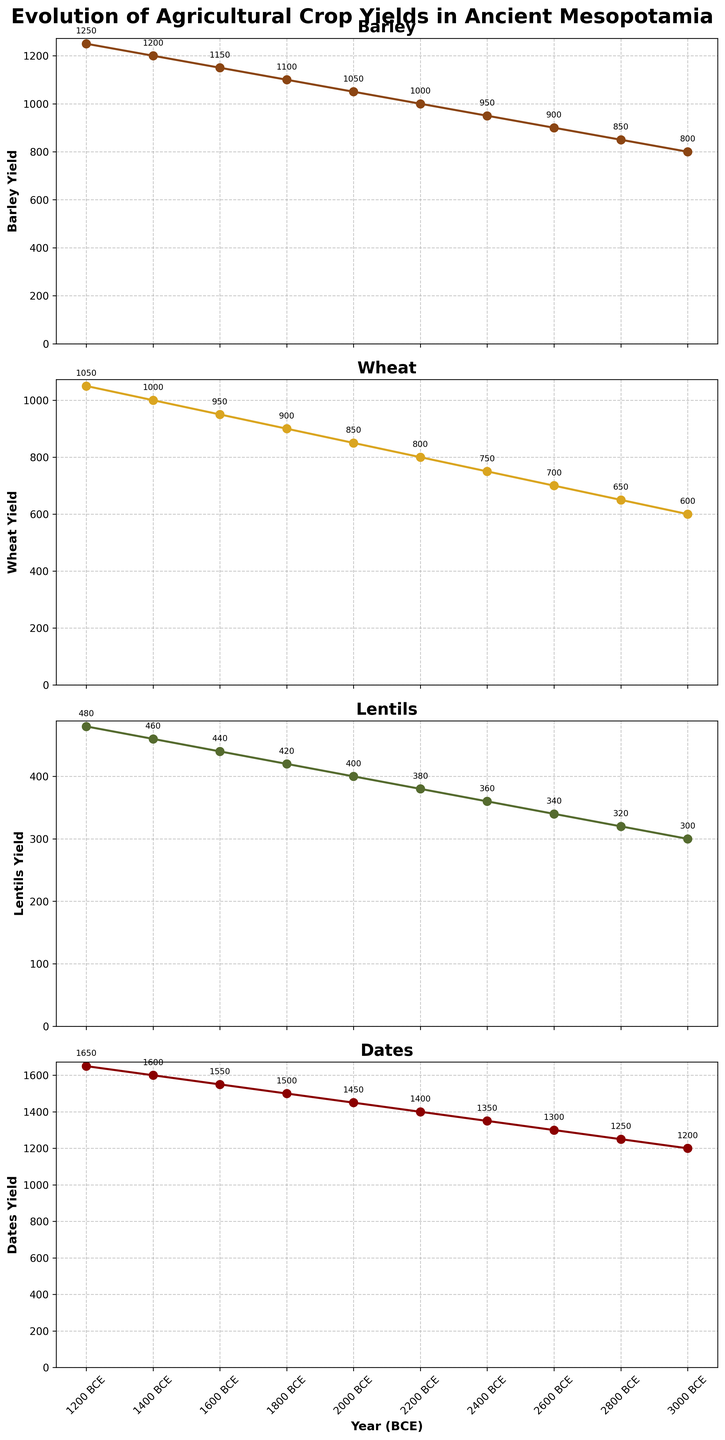What is the title of each subplot? Each subplot is titled with the name of the specific crop being represented. The four titles are "Barley," "Wheat," "Lentils," and "Dates."
Answer: Barley, Wheat, Lentils, Dates How many data points are there for each crop on the graph? The x-axis represents 'Year (BCE)' with tick marks for years 3000, 2800, 2600, 2400, 2200, 2000, 1800, 1600, 1400, and 1200 BCE. These are common to each subplot, so each crop has 10 data points.
Answer: 10 Which crop has the highest yield in 3000 BCE? To determine which crop has the highest yield in 3000 BCE, we need to look at the data points for the year 3000 BCE across all subplots. The yields are 800 for Barley, 600 for Wheat, 300 for Lentils, and 1200 for Dates. So, Dates have the highest yield in 3000 BCE.
Answer: Dates What is the overall trend for Lentils' yield from 3000 BCE to 1200 BCE? The line for Lentils' yield starts at 300 in 3000 BCE and gradually increases to 480 in 1200 BCE. This consistent upward trend indicates that the yield of Lentils progressively increased over this period.
Answer: Increasing Which crop shows the largest increase in yield from 3000 BCE to 1200 BCE? We need to calculate the difference in yield from 3000 BCE to 1200 BCE for each crop. Barley: 1250-800=450; Wheat: 1050-600=450; Lentils: 480-300=180; Dates: 1650-1200=450. Barley, Wheat, and Dates each show an increase of 450, the largest increase.
Answer: Barley, Wheat, Dates What is the combined yield of Barley and Wheat in 2400 BCE? Barley yield in 2400 BCE is 950 and Wheat yield in 2400 BCE is 750. Adding these yields gives us 950 + 750 = 1700.
Answer: 1700 Which year has the same yield for both Barley and Wheat? We need to visually inspect the lines for Barley and Wheat to find any year where the yields overlap. In this data, there is no year in which the yields for Barley and Wheat are the same.
Answer: None Between 1600 BCE and 1200 BCE, which crop had the fastest rate of increase in yield? Calculate the increase in yields over these years: Barley: 1250-1150=100; Wheat: 1050-950=100; Lentils: 480-440=40; Dates: 1650-1550=100. Barley, Wheat, and Dates each showed an increase of 100, which is the fastest rate among the crops.
Answer: Barley, Wheat, Dates At what year do the yield trends of Barley and Wheat parallel each other the most closely? Review the overall trend lines for both Barley and Wheat across all years to determine where their slopes appear most similar. Both Barley and Wheat exhibit consistent, linear increases at equivalent rates over the entire timeline, implying that their trends parallel each other fairly consistently across all years.
Answer: Throughout the timeline 